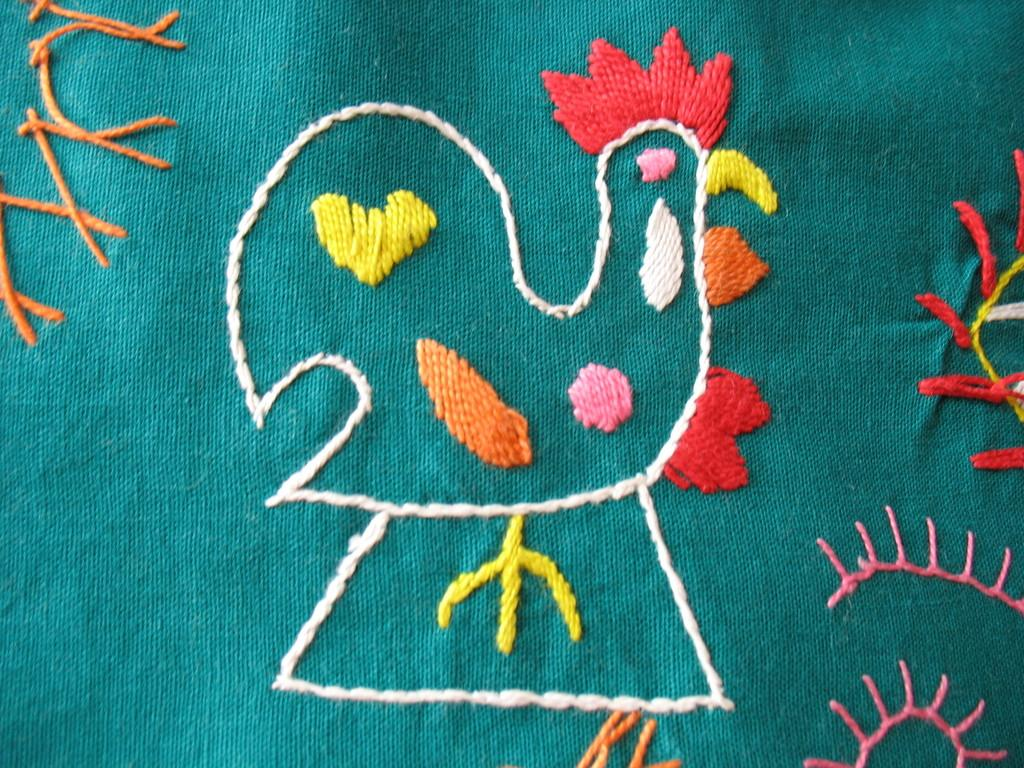What type of design can be seen on the cloth in the image? There is embroidery on the cloth in the image. How many rabbits are hopping around the pot in the image? There are no rabbits or pots present in the image; it only features embroidery on cloth. What time is displayed on the watch in the image? There is no watch present in the image; it only features embroidery on cloth. 